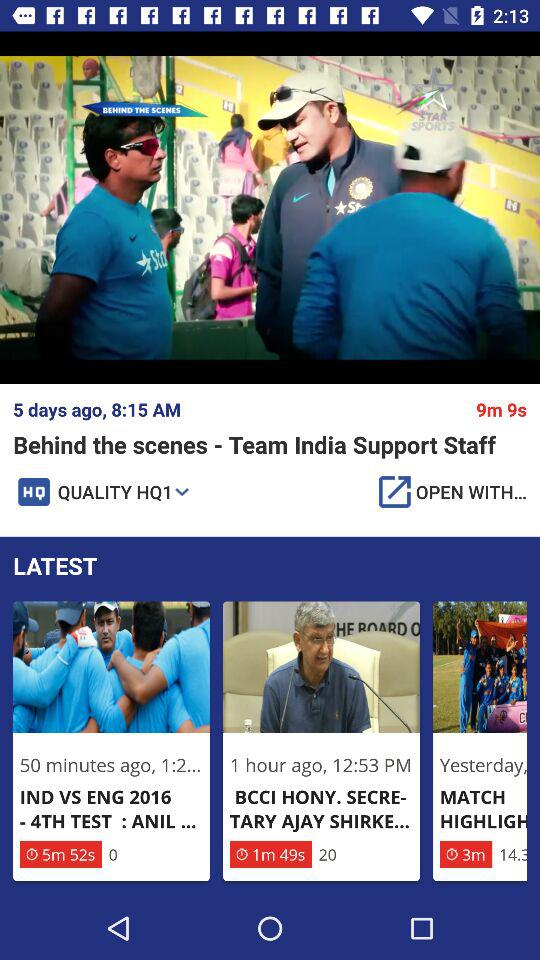What is the publication date of behind the scenes-team india support staff?
When the provided information is insufficient, respond with <no answer>. <no answer> 